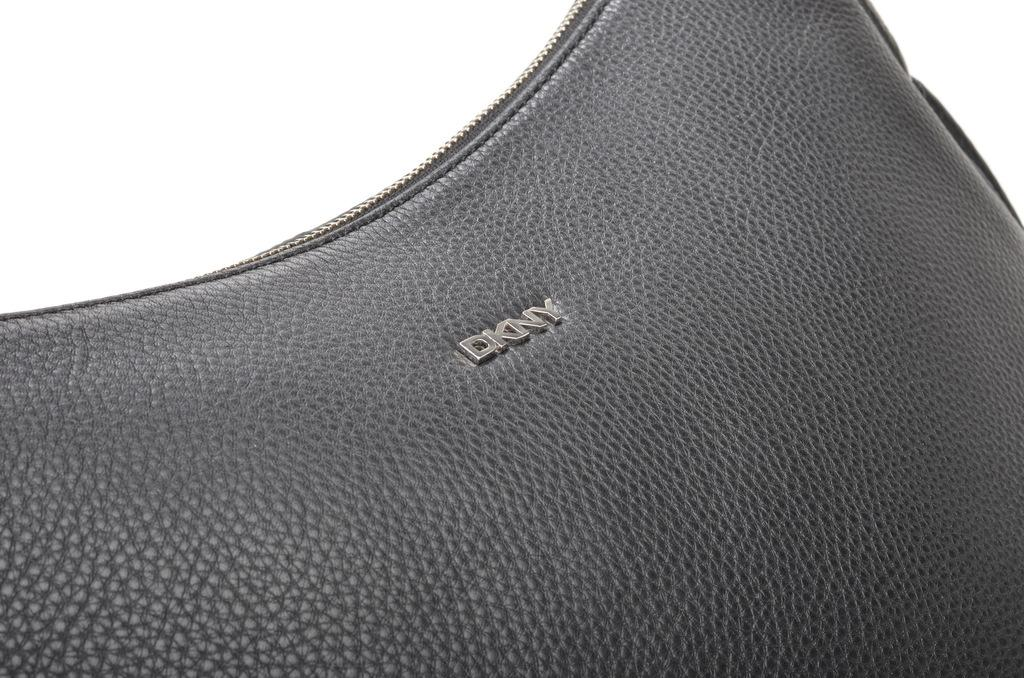What is the main subject of the image? The main subject of the image is a bag. Can you describe the focus of the image? The image is a zoomed in picture of the bag. How many beans are visible in the image? There are no beans present in the image; it is a picture of a bag. What type of flowers can be seen growing out of the bag in the image? There are no flowers present in the image; it is a picture of a bag. 